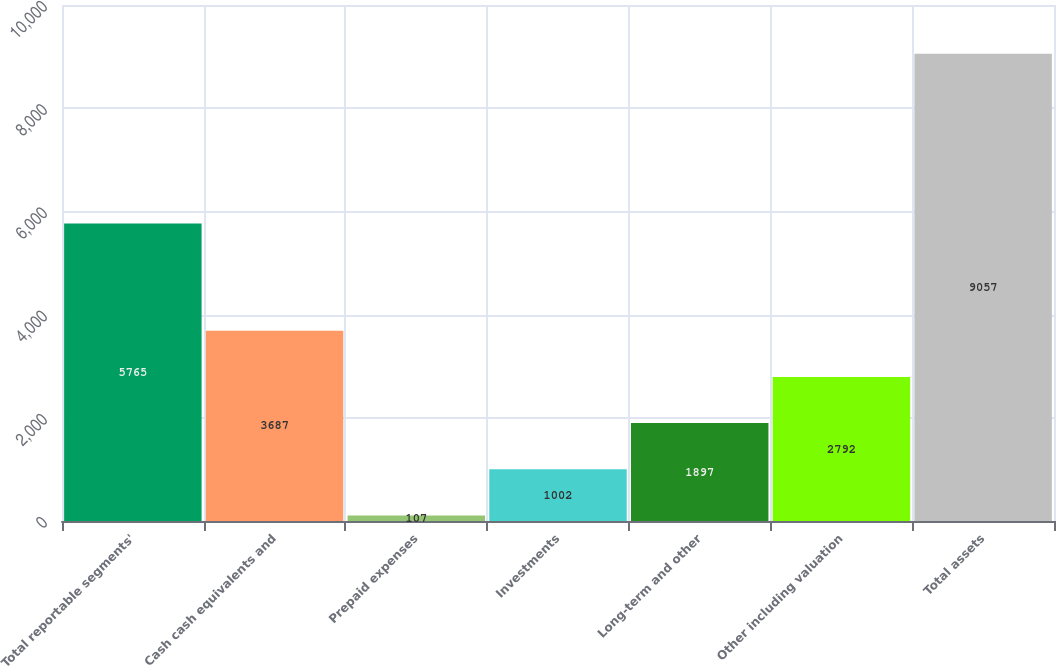Convert chart to OTSL. <chart><loc_0><loc_0><loc_500><loc_500><bar_chart><fcel>Total reportable segments'<fcel>Cash cash equivalents and<fcel>Prepaid expenses<fcel>Investments<fcel>Long-term and other<fcel>Other including valuation<fcel>Total assets<nl><fcel>5765<fcel>3687<fcel>107<fcel>1002<fcel>1897<fcel>2792<fcel>9057<nl></chart> 